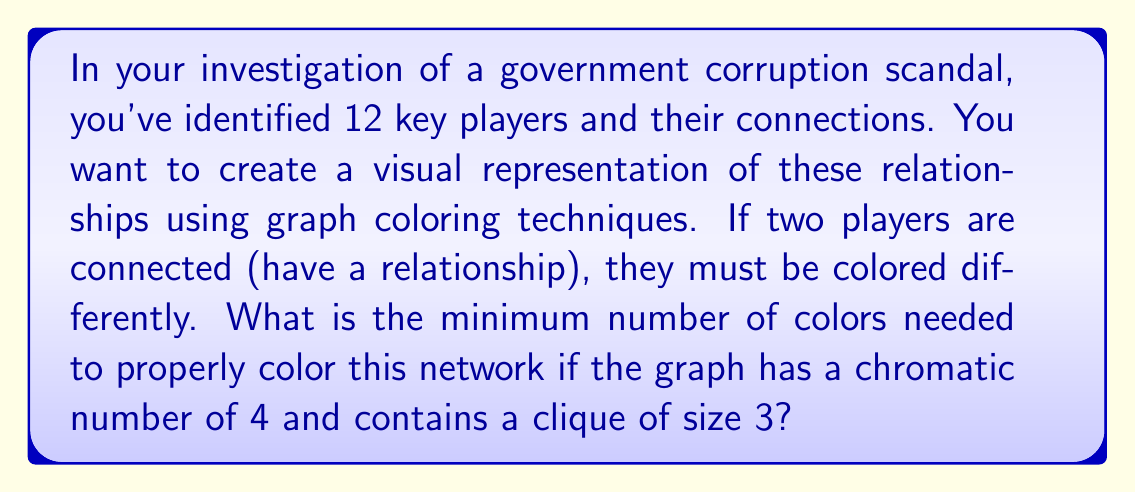Can you answer this question? To solve this problem, we need to understand a few key concepts from graph theory:

1. Chromatic number: The chromatic number of a graph, denoted as $\chi(G)$, is the minimum number of colors needed to color the vertices of the graph such that no two adjacent vertices share the same color.

2. Clique: A clique is a subset of vertices in a graph where every two distinct vertices are adjacent (connected by an edge).

Given information:
- The graph has a chromatic number of 4, i.e., $\chi(G) = 4$
- The graph contains a clique of size 3

Step 1: Understand the implications of the chromatic number.
The chromatic number being 4 means that we need at least 4 colors to properly color the graph. This is our lower bound.

Step 2: Consider the clique of size 3.
A clique of size 3 means that there are three vertices that are all connected to each other. This forms a triangle in the graph. Each vertex in this clique must have a different color.

Step 3: Combine the information from steps 1 and 2.
The clique of size 3 requires 3 colors. However, the chromatic number is 4, which means there must be at least one more vertex in the graph that is connected to all three vertices in the clique, requiring a fourth color.

Step 4: Conclude the minimum number of colors needed.
Since the chromatic number is 4, and we've shown that 4 colors are indeed necessary (3 for the clique and 1 more for the additional connections), we can conclude that 4 is the minimum number of colors needed to properly color this network.

This coloring scheme allows for the visual representation of the corruption network, where connected individuals (those with relationships or shared involvement) are easily identifiable by their different colors.
Answer: 4 colors 